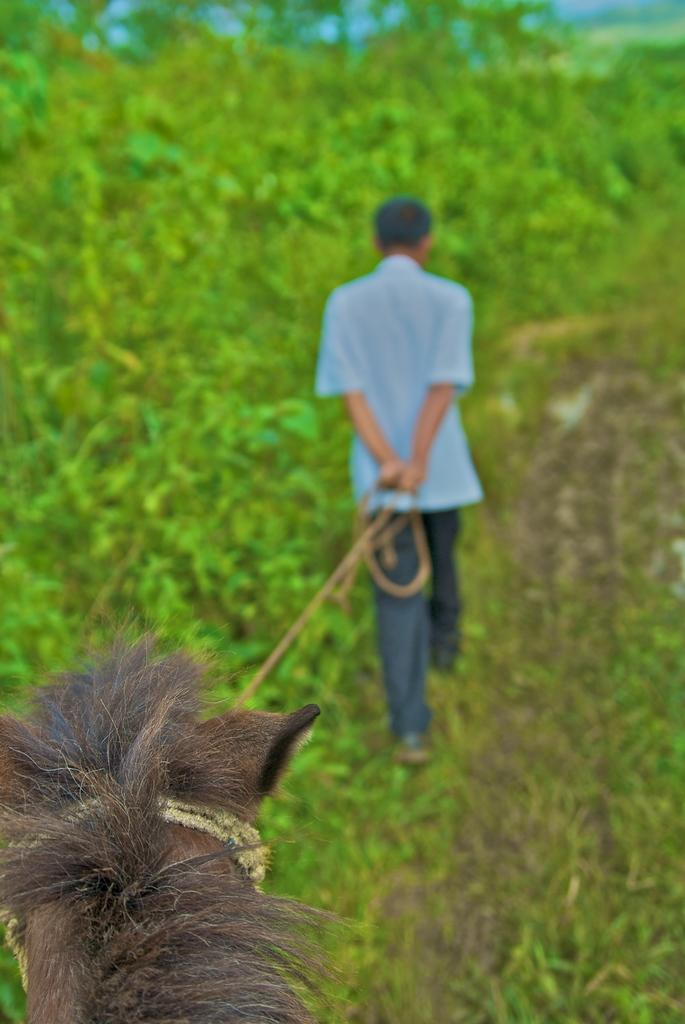Who is the main subject in the image? There is a man in the middle of the image. What is the man doing in the image? The man is holding an animal with a rope. What can be seen in the background of the image? There are trees beside the man. What type of slope can be seen in the image? There is no slope present in the image. What kind of cloth is the man wearing in the image? The provided facts do not mention any clothing worn by the man, so we cannot determine the type of cloth. 